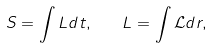<formula> <loc_0><loc_0><loc_500><loc_500>S = \int L d t , \quad L = \int \mathcal { L } d r ,</formula> 